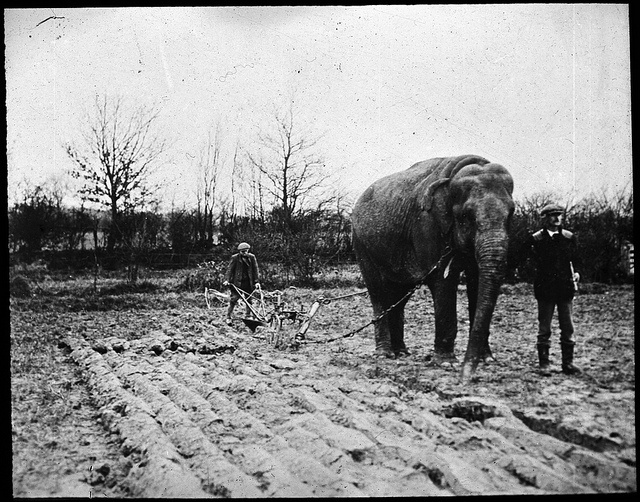Describe the objects in this image and their specific colors. I can see elephant in black, gray, darkgray, and lightgray tones, people in black, gray, darkgray, and lightgray tones, and people in black, gray, darkgray, and lightgray tones in this image. 